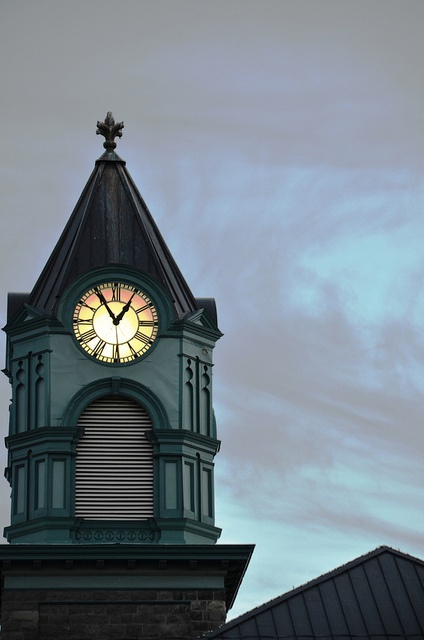Describe the objects in this image and their specific colors. I can see a clock in gray, khaki, black, ivory, and tan tones in this image. 